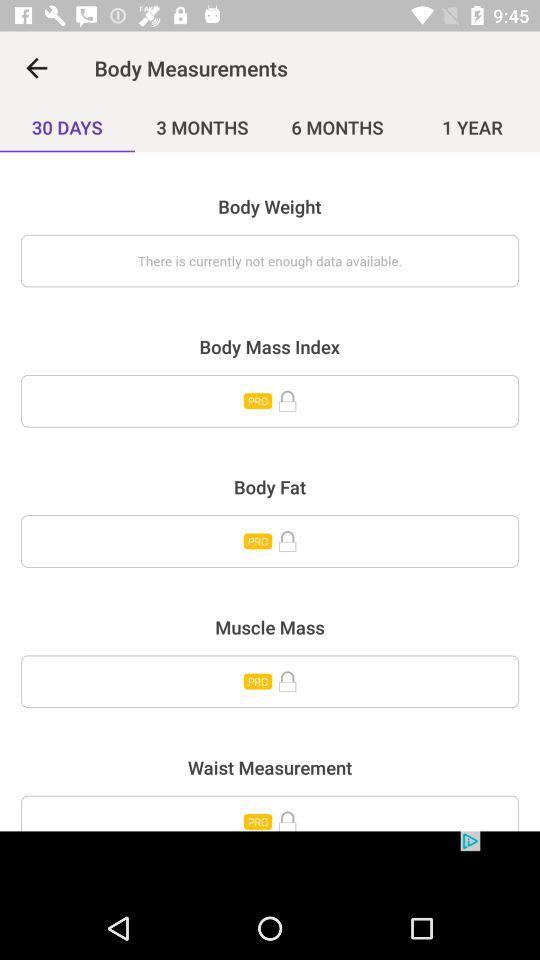Which tab is selected? The selected tab is "30 DAYS". 